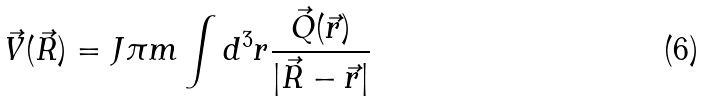<formula> <loc_0><loc_0><loc_500><loc_500>\vec { V } ( \vec { R } ) = J \pi m \int d ^ { 3 } r \frac { \vec { Q } ( \vec { r } ) } { | \vec { R } - \vec { r } | }</formula> 